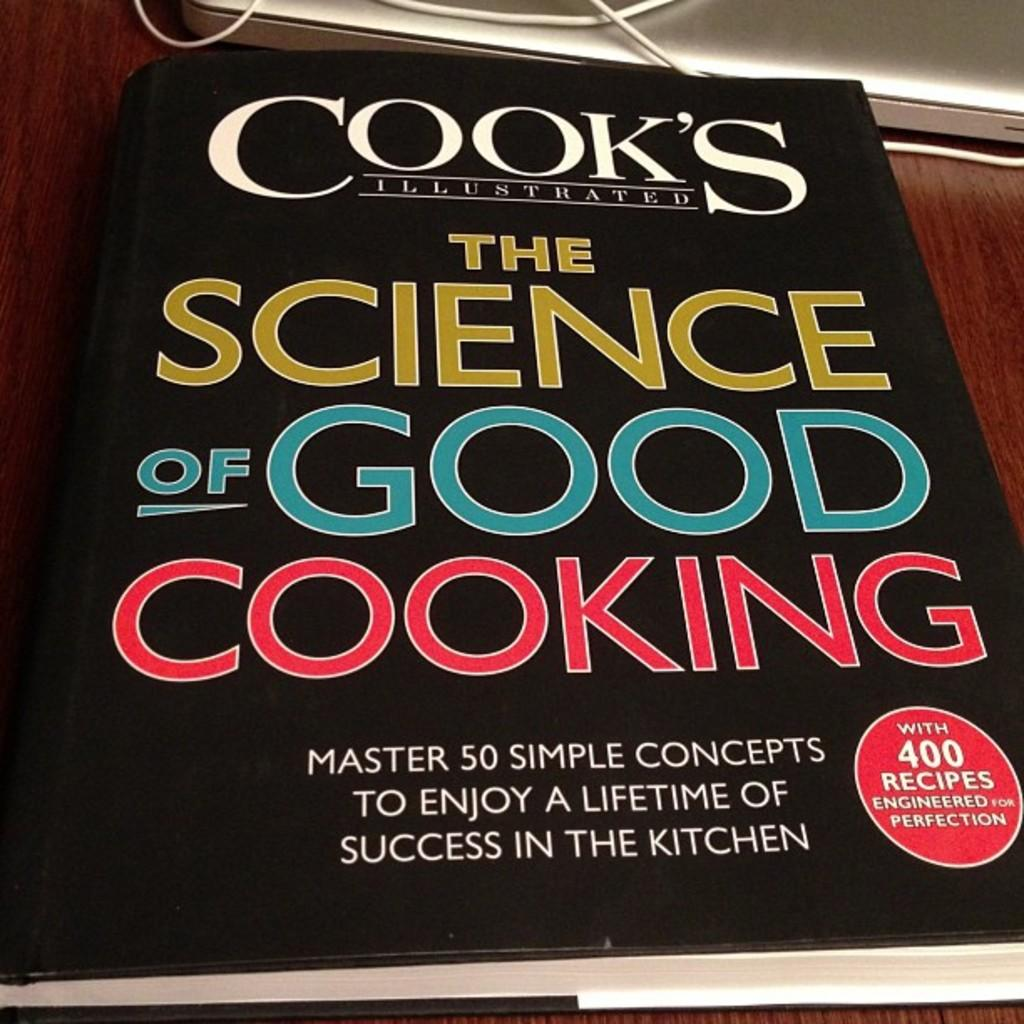<image>
Summarize the visual content of the image. Cook's Illustrated The Science of Good Cooking contains 400 recipes engineered for perfection. 